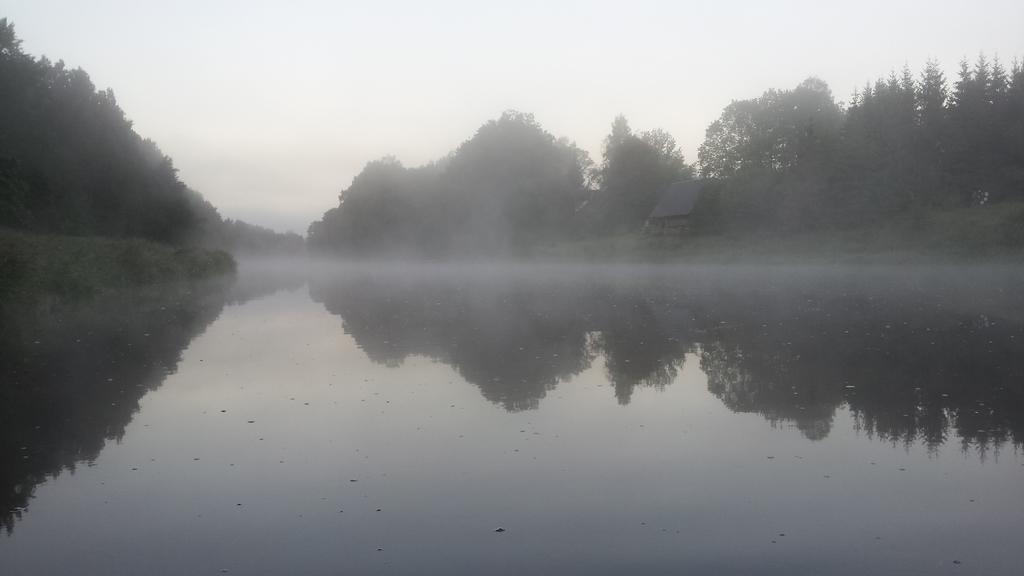Please provide a concise description of this image. In this image at the bottom there is pond and in the background there are some trees and plants and house. At the top there is sky. 